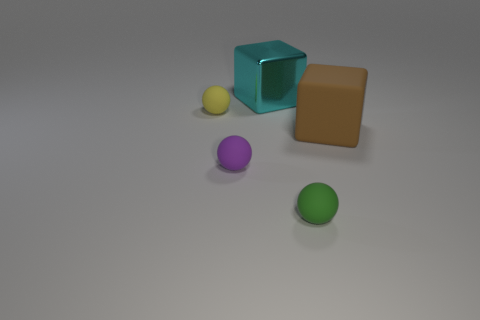What is the material of the big cyan object?
Offer a terse response. Metal. There is a big matte object; how many small green objects are in front of it?
Give a very brief answer. 1. Is the number of yellow rubber balls that are on the left side of the brown thing less than the number of small purple rubber objects?
Your answer should be compact. No. The shiny block has what color?
Offer a very short reply. Cyan. What is the color of the other object that is the same shape as the big brown object?
Make the answer very short. Cyan. How many big objects are cyan metallic blocks or cyan rubber blocks?
Your response must be concise. 1. There is a thing that is behind the tiny yellow ball; how big is it?
Offer a very short reply. Large. There is a matte object that is behind the large brown cube; what number of big brown rubber things are left of it?
Your response must be concise. 0. What number of large cubes are the same material as the purple sphere?
Your answer should be very brief. 1. Are there any matte things behind the tiny yellow thing?
Your answer should be very brief. No. 